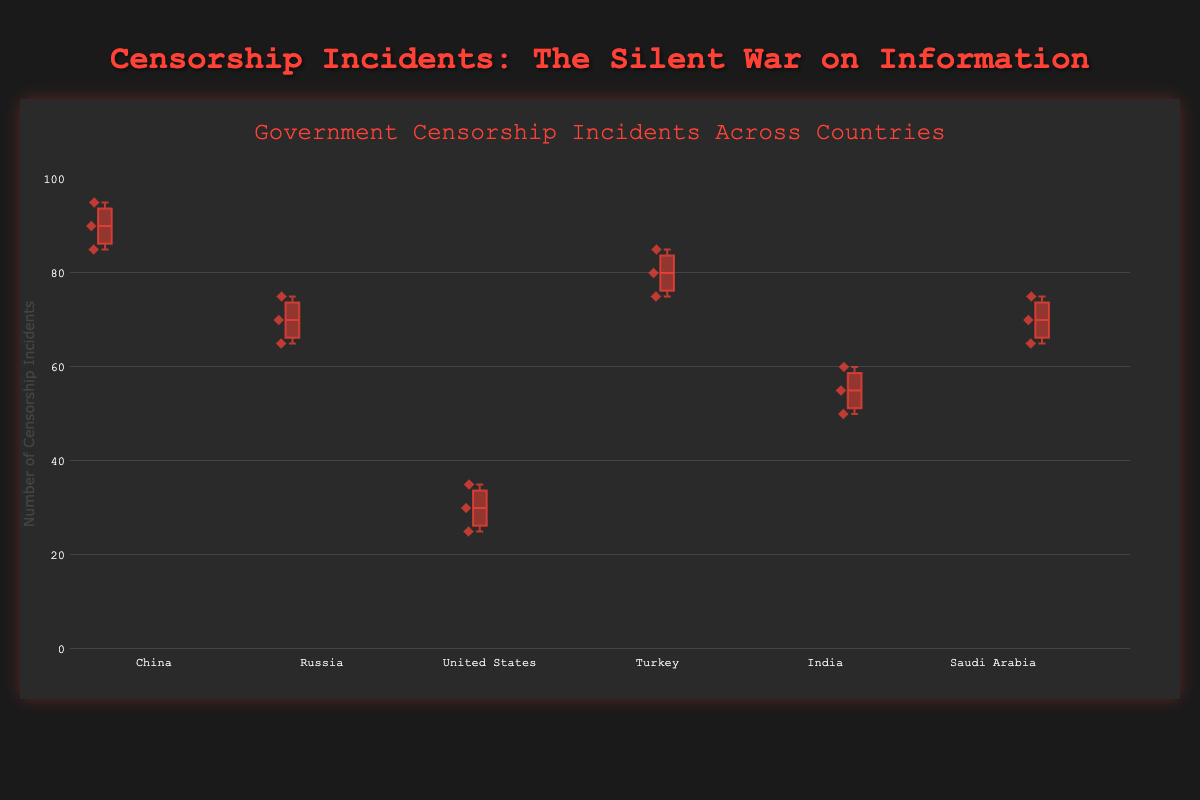What's the title of the plot? The title of the plot is located at the top and is typically larger and bolder than the rest of the text. The title for this plot is "Government Censorship Incidents Across Countries".
Answer: Government Censorship Incidents Across Countries Which country has the box plot with the highest upper whisker value? The upper whisker value on a box plot extends to the maximum data point within 1.5 times the Interquartile Range (IQR) from the third quartile (Q3). Look for the country whose whisker reaches the highest point on the y-axis.
Answer: China Compare the median censorship incidents of Turkey and the United States. Which is higher? The median is represented by the line inside each box plot. Observe the median lines for Turkey and the United States and compare their positions on the y-axis.
Answer: Turkey Which media outlet in China has the highest number of recorded censorship incidents? The data points for censorship incidents in each country can be identified within each box plot by the points above the boxes. In China's box plot, identify and compare values for the different media outlets.
Answer: CCTV What is the range of censorship incidents in India? The range is the difference between the maximum and minimum values. Look at the top and bottom ends of the whiskers for India's box plot to determine this.
Answer: 60 - 50 = 10 Which country has the highest median value of censorship incidents? The median value is the line inside each box plot. Identify which country’s median line is the highest on the y-axis.
Answer: China Is the IQR (Interquartile Range) of Russia larger than that of Saudi Arabia? The IQR is the height of the box in the box plot, which represents the range between the first quartile (Q1) and the third quartile (Q3). Compare the heights of the boxes for Russia and Saudi Arabia.
Answer: No What is the interquartile range (IQR) for Turkey? The IQR is the difference between the third quartile (Q3) and the first quartile (Q1). Identify the positions of Q1 and Q3 on the y-axis and subtract Q1 from Q3 for Turkey's box plot.
Answer: 85 - 75 = 10 Compare the median censorship incidents in Russia and India. Which has a lower median value? The median is represented by the line within the box plot. Compare the median lines for Russia and India and determine which one lies lower on the y-axis.
Answer: India 